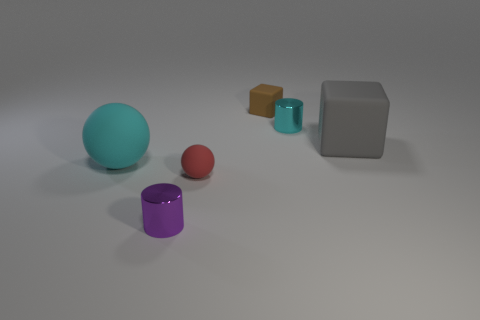What is the shape of the thing that is the same color as the big ball?
Give a very brief answer. Cylinder. What number of other things are there of the same size as the brown object?
Your answer should be very brief. 3. Is the number of brown cubes that are in front of the tiny cyan metal cylinder less than the number of matte things?
Offer a terse response. Yes. Is there anything else that is the same shape as the cyan matte thing?
Your answer should be compact. Yes. Is there a red matte sphere?
Provide a short and direct response. Yes. Is the number of big cyan spheres less than the number of matte objects?
Give a very brief answer. Yes. How many blue cylinders have the same material as the tiny brown cube?
Provide a succinct answer. 0. What color is the other sphere that is made of the same material as the red ball?
Your answer should be very brief. Cyan. The big cyan thing is what shape?
Offer a terse response. Sphere. What number of tiny rubber blocks have the same color as the big block?
Give a very brief answer. 0. 